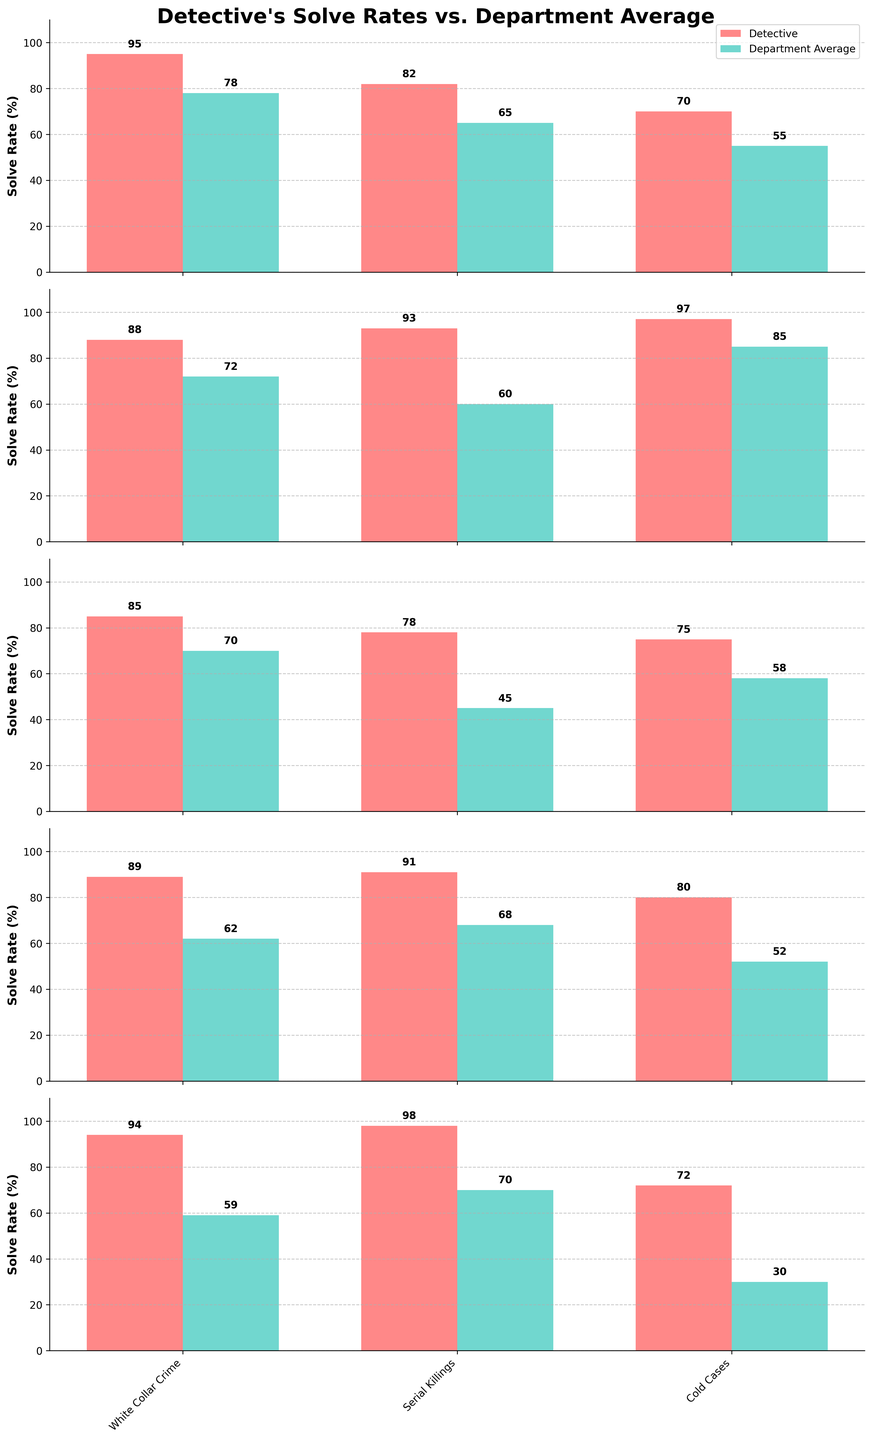How does the detective's solve rate for Cybercrime compare to the department average? The detective's solve rate for Cybercrime is shown as a red bar with a value of 78, whereas the department average is shown as a green bar with a value of 45. The detective has a higher solve rate.
Answer: Higher Which type of crime has the lowest solve rate for the detective? By examining the heights of the red bars across all subplots, Cold Cases has the lowest detective solve rate at 72.
Answer: Cold Cases What is the difference in the solve rate for White Collar Crime between the detective and the department average? The detective's solve rate for White Collar Crime is 94 and the department average is 59. The difference is calculated by 94 - 59 = 35.
Answer: 35 Which crime type has the smallest gap between the detective's solve rate and the department average? For each crime type, find the absolute differences and identify the smallest: Homicide (95-78=17), Robbery (82-65=17), and Kidnapping (97-85=12). Kidnapping has the smallest gap.
Answer: Kidnapping If the department's average solve rate for Cold Cases was doubled, would the detective still have a higher rate? Double the department average for Cold Cases: 30 * 2 = 60. The detective's rate for Cold Cases is 72, which is still higher.
Answer: Yes How many crime types have a department average solve rate that is at least 20 points lower than the detective's solve rate? Calculate the difference for each crime type and count those that are 20 points lower: Homicide (17), Robbery (17), Burglary (15), Assault (16), Fraud (33), Kidnapping (12), Drug Trafficking (15), Cybercrime (33), Grand Theft Auto (17), Arson (27), Forgery (23), Organized Crime (28), White Collar Crime (35), Serial Killings (28), Cold Cases (42). There are 10 such crime types.
Answer: 10 What are the median solve rates for the department average? Organize the department average solve rates and find the middle values: 30, 45, 52, 55, 58, 59, 60, 62, 65, 68, 70, 72, 78, 85. The median lies between 60 and 62, so the median is (60 + 62) / 2 = 61.
Answer: 61 